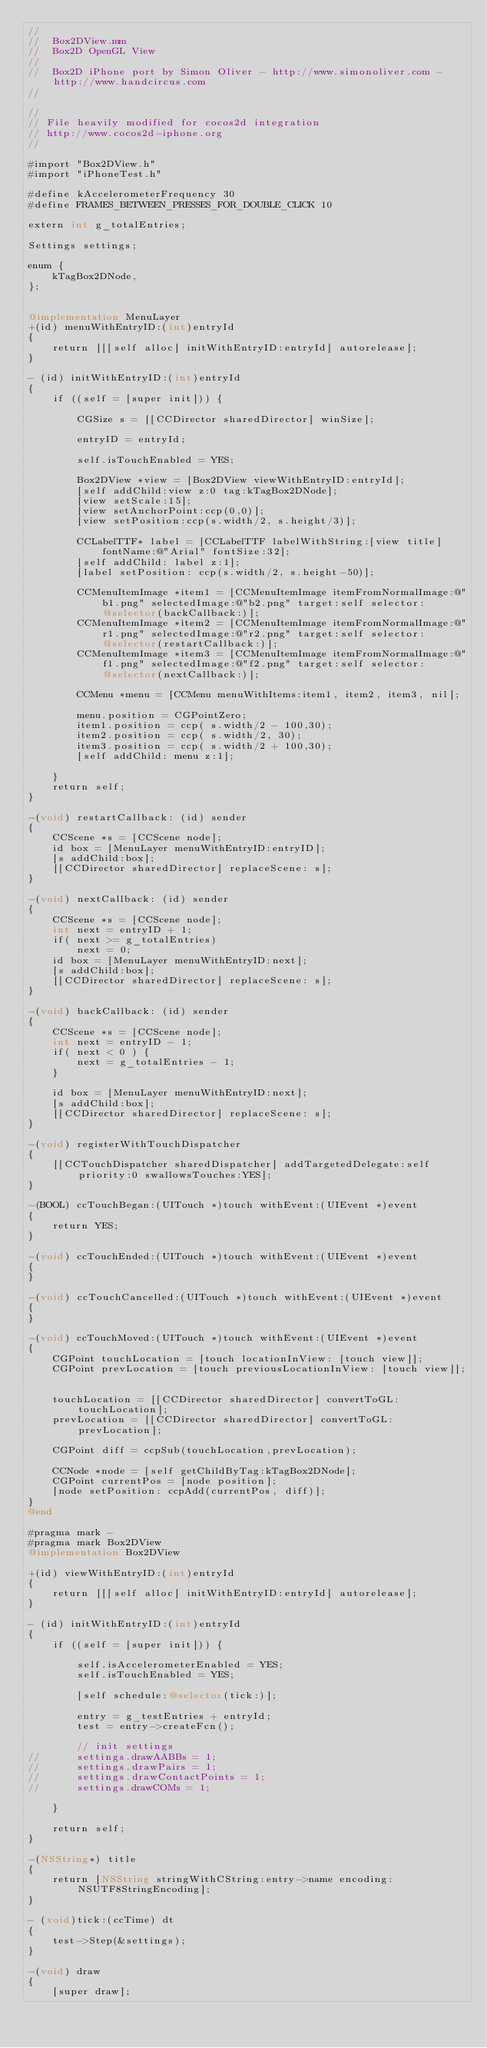Convert code to text. <code><loc_0><loc_0><loc_500><loc_500><_ObjectiveC_>//
//  Box2DView.mm
//  Box2D OpenGL View
//
//  Box2D iPhone port by Simon Oliver - http://www.simonoliver.com - http://www.handcircus.com
//

//
// File heavily modified for cocos2d integration
// http://www.cocos2d-iphone.org
//

#import "Box2DView.h"
#import "iPhoneTest.h"

#define kAccelerometerFrequency 30
#define FRAMES_BETWEEN_PRESSES_FOR_DOUBLE_CLICK 10

extern int g_totalEntries;

Settings settings;

enum {
	kTagBox2DNode,
};


@implementation MenuLayer
+(id) menuWithEntryID:(int)entryId
{
	return [[[self alloc] initWithEntryID:entryId] autorelease];
}

- (id) initWithEntryID:(int)entryId
{
	if ((self = [super init])) {
		
		CGSize s = [[CCDirector sharedDirector] winSize];
		
		entryID = entryId;
		
		self.isTouchEnabled = YES;
		
		Box2DView *view = [Box2DView viewWithEntryID:entryId];
		[self addChild:view z:0 tag:kTagBox2DNode];
		[view setScale:15];
		[view setAnchorPoint:ccp(0,0)];
		[view setPosition:ccp(s.width/2, s.height/3)];
		
		CCLabelTTF* label = [CCLabelTTF labelWithString:[view title] fontName:@"Arial" fontSize:32];
		[self addChild: label z:1];
		[label setPosition: ccp(s.width/2, s.height-50)];
		
		CCMenuItemImage *item1 = [CCMenuItemImage itemFromNormalImage:@"b1.png" selectedImage:@"b2.png" target:self selector:@selector(backCallback:)];
		CCMenuItemImage *item2 = [CCMenuItemImage itemFromNormalImage:@"r1.png" selectedImage:@"r2.png" target:self selector:@selector(restartCallback:)];
		CCMenuItemImage *item3 = [CCMenuItemImage itemFromNormalImage:@"f1.png" selectedImage:@"f2.png" target:self selector:@selector(nextCallback:)];
		
		CCMenu *menu = [CCMenu menuWithItems:item1, item2, item3, nil];
		
		menu.position = CGPointZero;
		item1.position = ccp( s.width/2 - 100,30);
		item2.position = ccp( s.width/2, 30);
		item3.position = ccp( s.width/2 + 100,30);
		[self addChild: menu z:1];		

	}
	return self;
}

-(void) restartCallback: (id) sender
{
	CCScene *s = [CCScene node];
	id box = [MenuLayer menuWithEntryID:entryID];
	[s addChild:box];
	[[CCDirector sharedDirector] replaceScene: s];
}

-(void) nextCallback: (id) sender
{
	CCScene *s = [CCScene node];
	int next = entryID + 1;
	if( next >= g_totalEntries)
		next = 0;
	id box = [MenuLayer menuWithEntryID:next];
	[s addChild:box];
	[[CCDirector sharedDirector] replaceScene: s];
}

-(void) backCallback: (id) sender
{
	CCScene *s = [CCScene node];
	int next = entryID - 1;
	if( next < 0 ) {
		next = g_totalEntries - 1;
	}
	
	id box = [MenuLayer menuWithEntryID:next];
	[s addChild:box];
	[[CCDirector sharedDirector] replaceScene: s];
}

-(void) registerWithTouchDispatcher
{
	[[CCTouchDispatcher sharedDispatcher] addTargetedDelegate:self priority:0 swallowsTouches:YES];
}

-(BOOL) ccTouchBegan:(UITouch *)touch withEvent:(UIEvent *)event
{
	return YES;
}

-(void) ccTouchEnded:(UITouch *)touch withEvent:(UIEvent *)event
{
}

-(void) ccTouchCancelled:(UITouch *)touch withEvent:(UIEvent *)event
{
}

-(void) ccTouchMoved:(UITouch *)touch withEvent:(UIEvent *)event
{
	CGPoint touchLocation = [touch locationInView: [touch view]];	
	CGPoint prevLocation = [touch previousLocationInView: [touch view]];	
	
	touchLocation = [[CCDirector sharedDirector] convertToGL: touchLocation];
	prevLocation = [[CCDirector sharedDirector] convertToGL: prevLocation];
	
	CGPoint diff = ccpSub(touchLocation,prevLocation);
	
	CCNode *node = [self getChildByTag:kTagBox2DNode];
	CGPoint currentPos = [node position];
	[node setPosition: ccpAdd(currentPos, diff)];
}
@end

#pragma mark -
#pragma mark Box2DView
@implementation Box2DView

+(id) viewWithEntryID:(int)entryId
{
	return [[[self alloc] initWithEntryID:entryId] autorelease];
}

- (id) initWithEntryID:(int)entryId
{    
    if ((self = [super init])) {
		
		self.isAccelerometerEnabled = YES;
		self.isTouchEnabled = YES;

		[self schedule:@selector(tick:)];

		entry = g_testEntries + entryId;
		test = entry->createFcn();
		
		// init settings
//		settings.drawAABBs = 1;
//		settings.drawPairs = 1;
//		settings.drawContactPoints = 1;
//		settings.drawCOMs = 1;
		
    }
		
    return self;
}

-(NSString*) title
{
	return [NSString stringWithCString:entry->name encoding:NSUTF8StringEncoding];
}

- (void)tick:(ccTime) dt
{
	test->Step(&settings);
}

-(void) draw
{
	[super draw];
</code> 